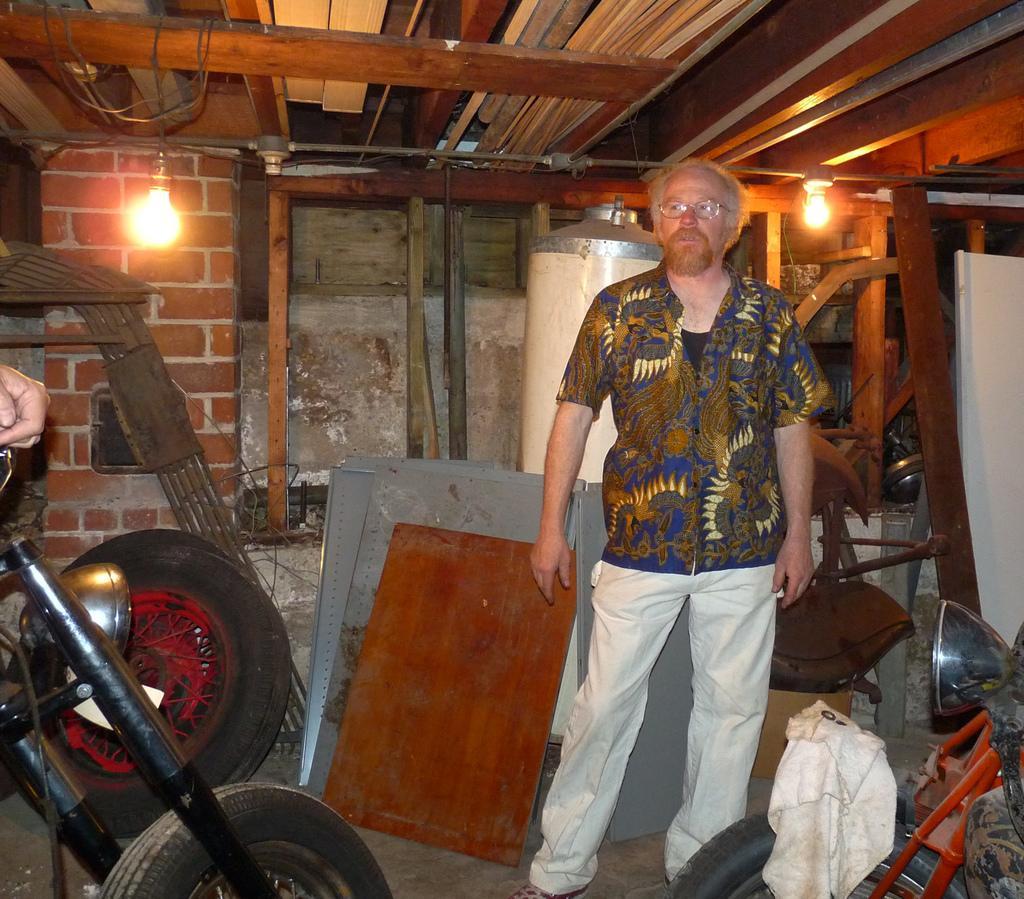How would you summarize this image in a sentence or two? In this picture we can see some spare parts inside the room and one person is standing, we can see two lights. 